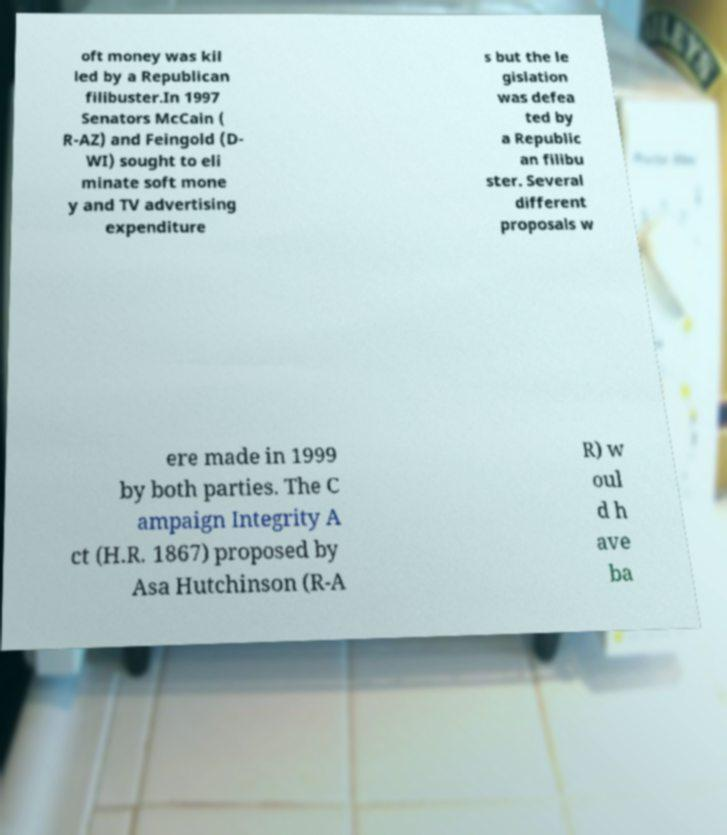Could you extract and type out the text from this image? oft money was kil led by a Republican filibuster.In 1997 Senators McCain ( R-AZ) and Feingold (D- WI) sought to eli minate soft mone y and TV advertising expenditure s but the le gislation was defea ted by a Republic an filibu ster. Several different proposals w ere made in 1999 by both parties. The C ampaign Integrity A ct (H.R. 1867) proposed by Asa Hutchinson (R-A R) w oul d h ave ba 